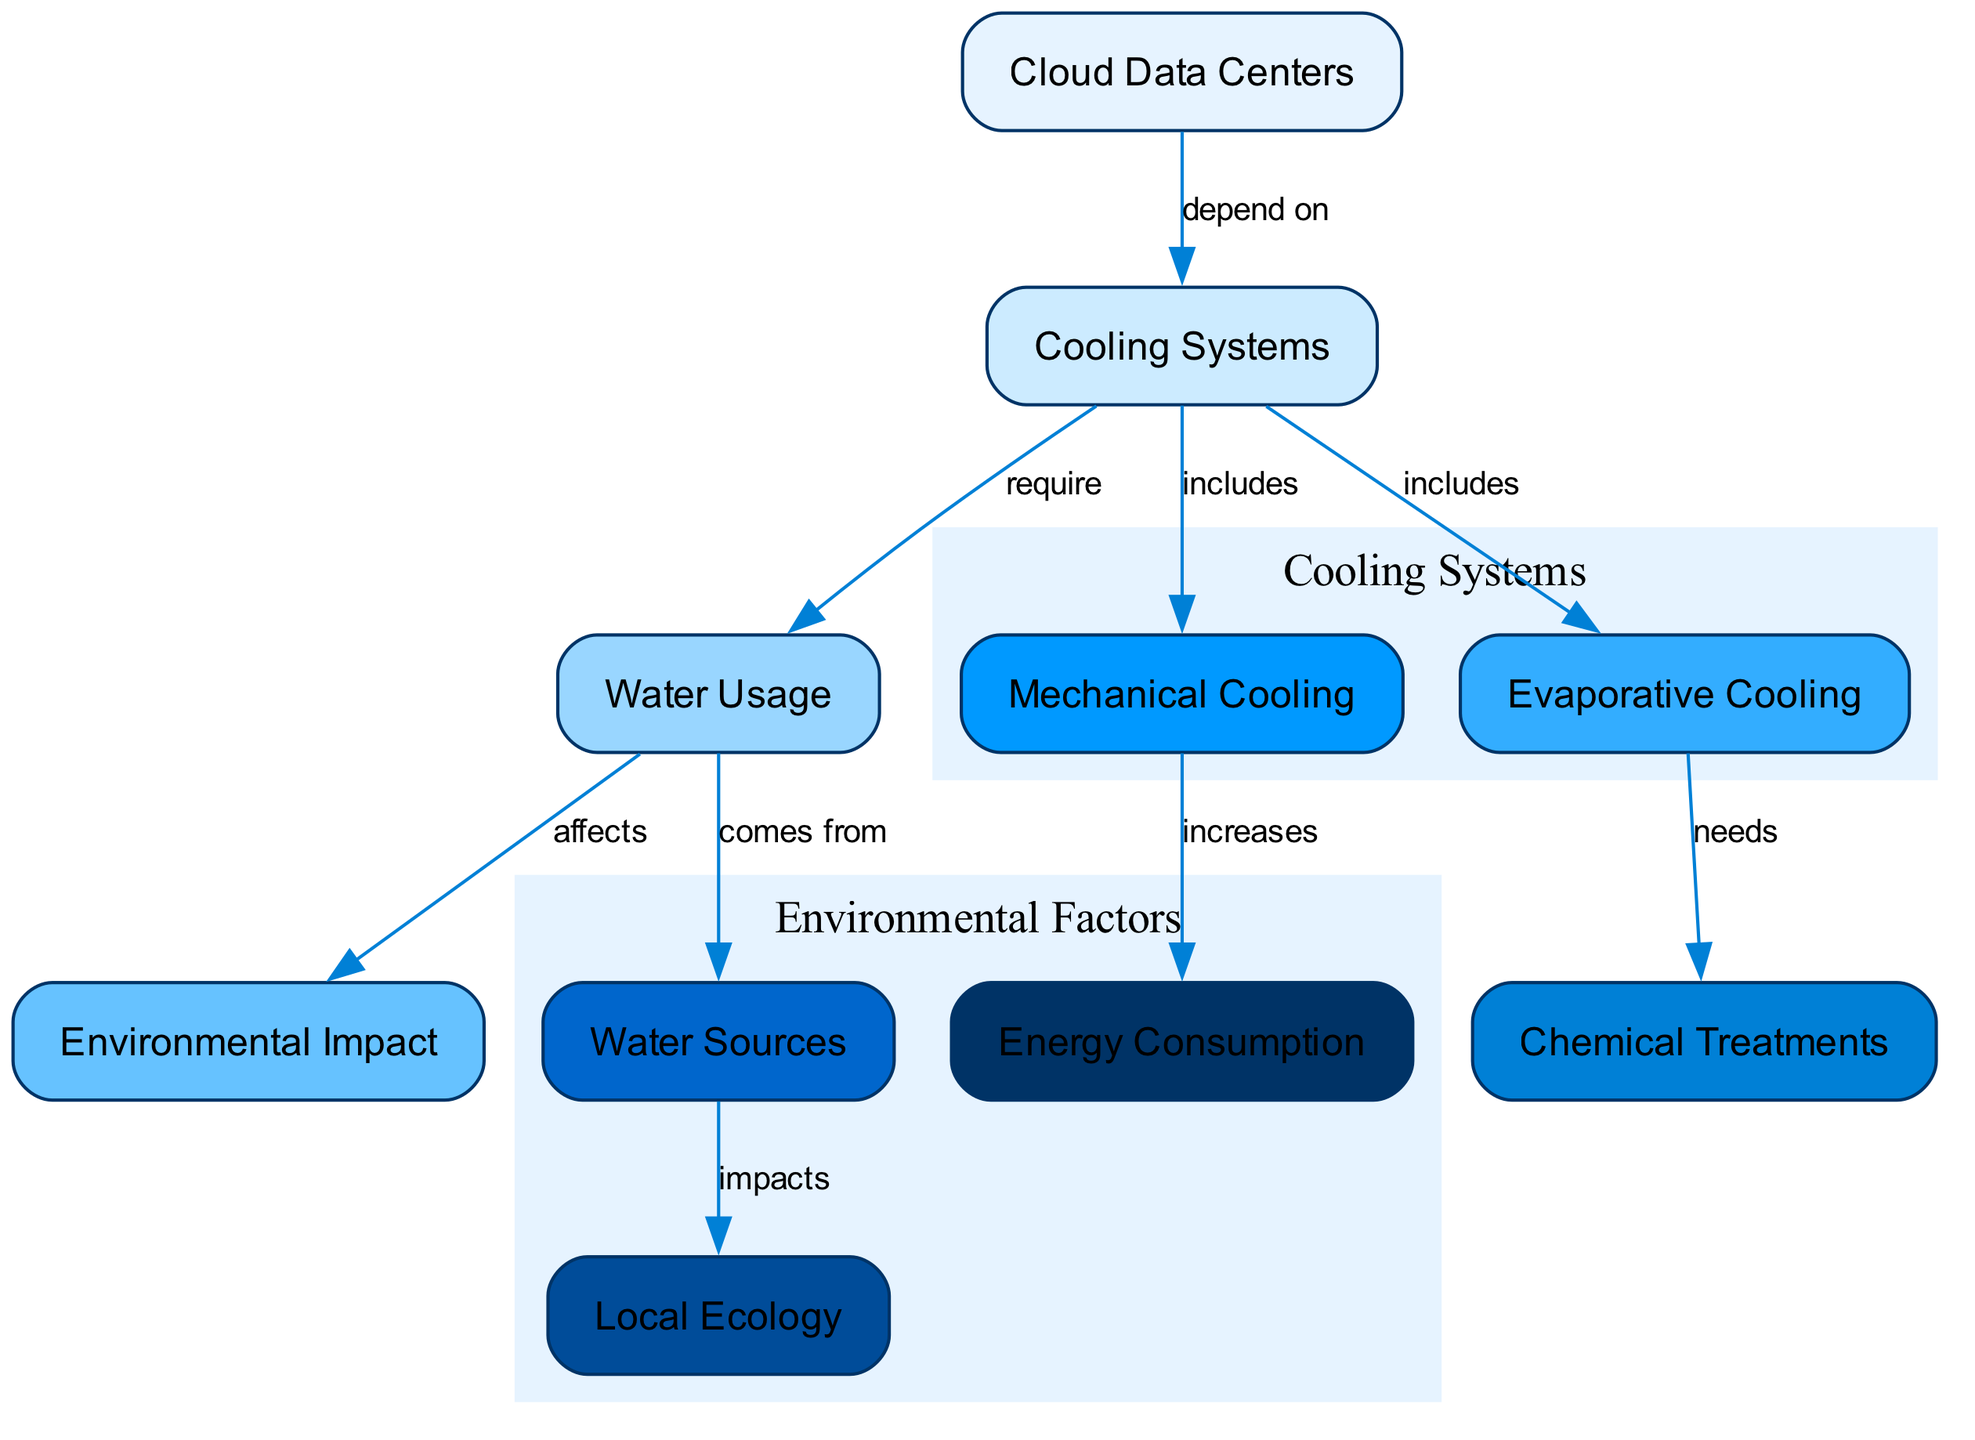What do cloud data centers depend on? The diagram shows an edge from "Cloud Data Centers" to "Cooling Systems" labeled "depend on", indicating that cloud data centers require cooling systems for operation.
Answer: Cooling Systems What type of cooling system uses water? The diagram illustrates that "Cooling Systems" includes both "Evaporative Cooling" and "Mechanical Cooling". The term "Evaporative Cooling" specifically implies a type of cooling that utilizes water.
Answer: Evaporative Cooling How does water usage affect the environment? There is an edge from "Water Usage" to "Environmental Impact" labeled "affects", suggesting that the volume of water used in cloud data centers has implications for the surrounding environment.
Answer: Affects What impacts local ecology? The diagram indicates that "Water Sources" has an edge to "Local Ecology" labeled "impacts", indicating that the source of the water used can significantly influence the local ecosystem.
Answer: Water Sources What are the two types of cooling systems listed? The diagram has nodes under "Cooling Systems" labeled as "Evaporative Cooling" and "Mechanical Cooling", indicating these are the types of cooling systems relevant to the data centers.
Answer: Evaporative Cooling, Mechanical Cooling Which cooling system increases energy consumption? The diagram connects "Mechanical Cooling" to "Energy Consumption" with an edge labeled "increases", meaning that mechanical cooling contributes to higher energy usage.
Answer: Mechanical Cooling From where does water usage come? The diagram illustrates that "Water Usage" is linked to "Water Sources" labeled "comes from", indicating the origin of water consumed by cooling systems.
Answer: Water Sources What is necessary for evaporative cooling? According to the diagram, "Evaporative Cooling" has an edge to "Chemical Treatments" labeled "needs", implying that specific chemical treatments are required for the process.
Answer: Chemical Treatments How many nodes are related to environmental impact? The diagram shows one direct connection between "Water Usage" and "Environmental Impact" indicating that there is one node concerned with its environmental implications directly.
Answer: One Which system is included in cooling systems but doesn’t require chemical treatments? The diagram lists "Mechanical Cooling" under the node "Cooling Systems", but there is no direct connection to "Chemical Treatments", implying it may operate without them.
Answer: Mechanical Cooling 